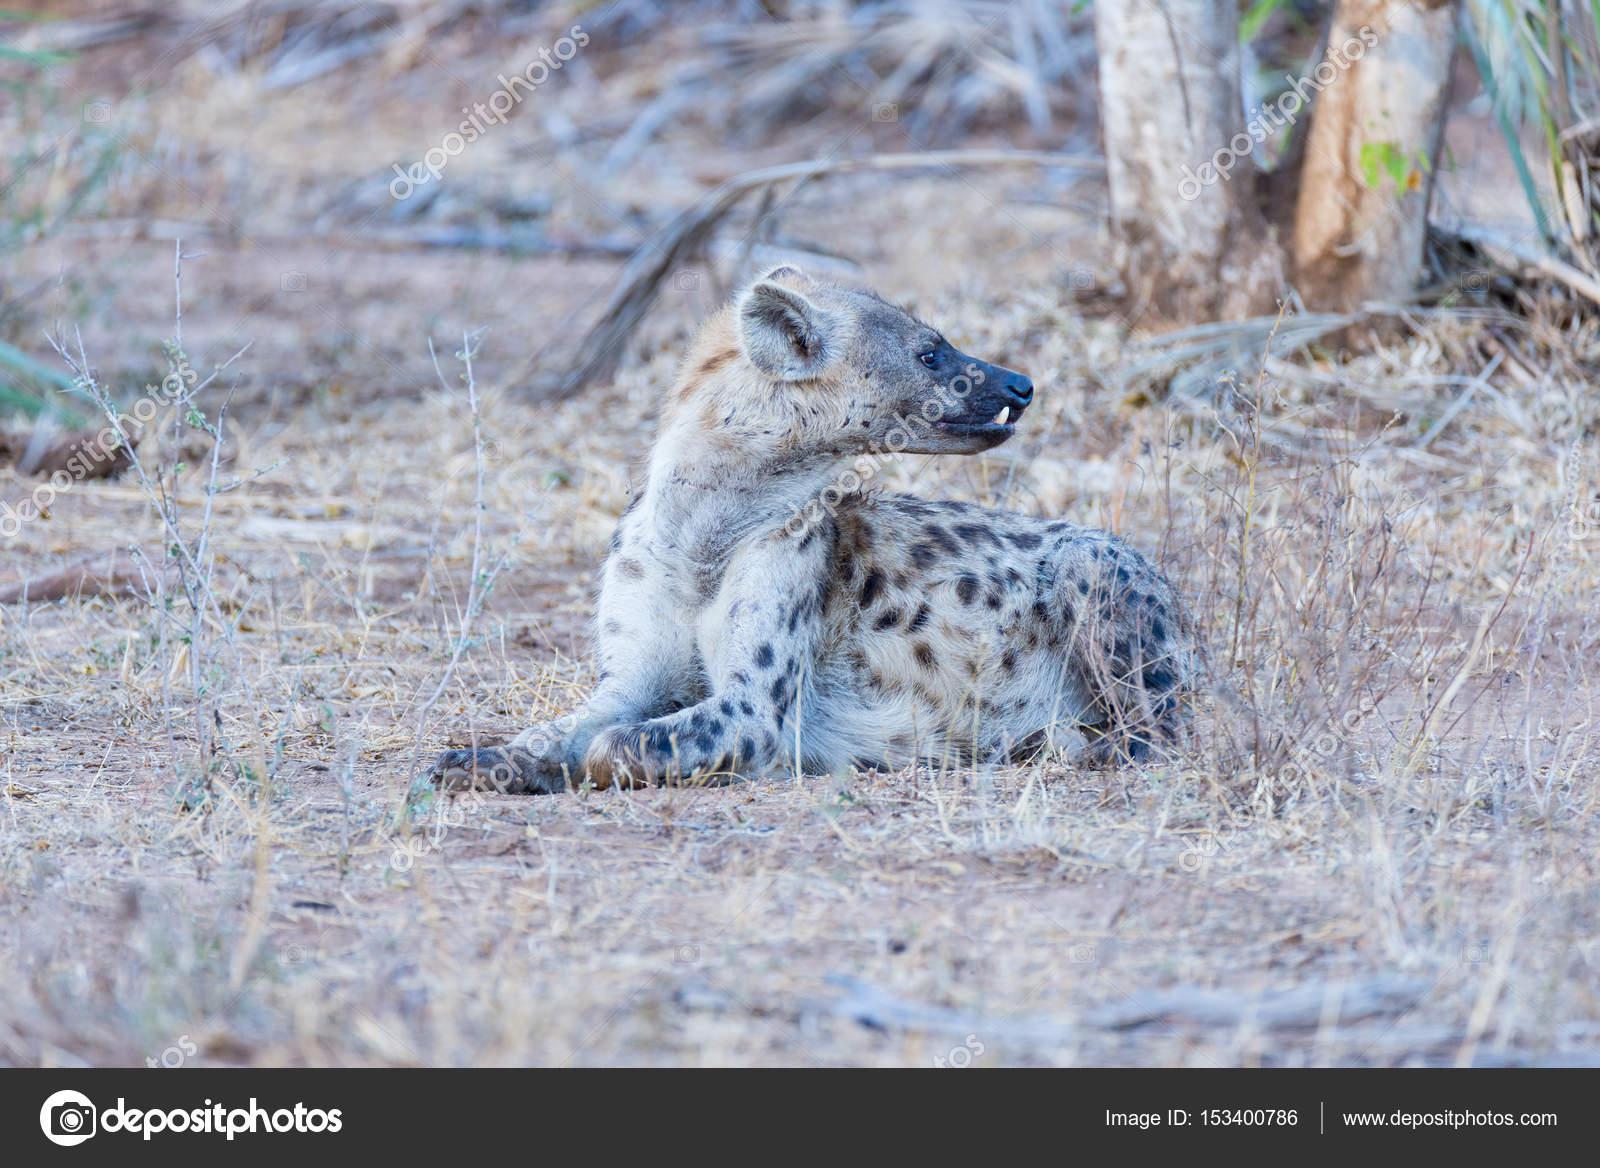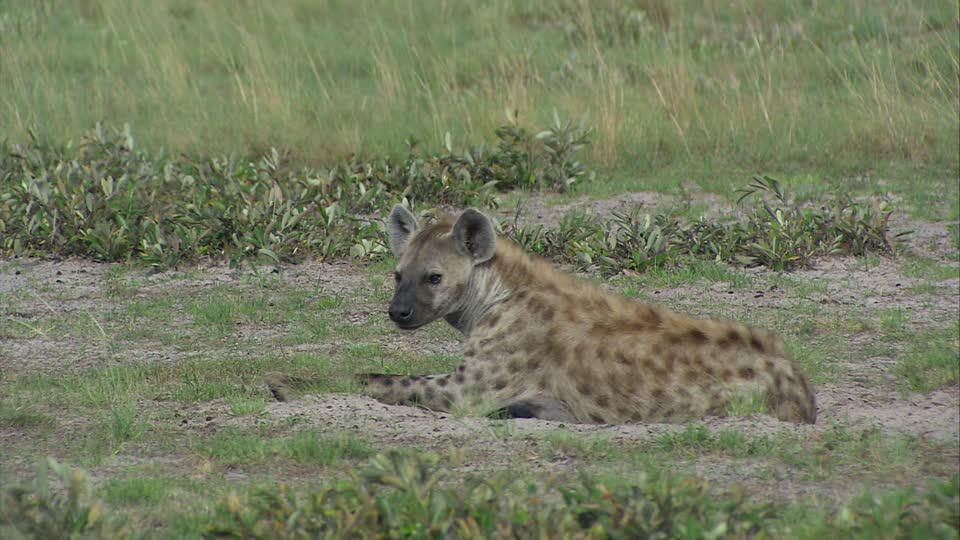The first image is the image on the left, the second image is the image on the right. Assess this claim about the two images: "Each image features one hyena with distinctive spotted fur, and the hyena on the left has its head turned around, while the hyena on the right reclines with its front paws extended.". Correct or not? Answer yes or no. Yes. The first image is the image on the left, the second image is the image on the right. Assess this claim about the two images: "There is a single adult hyena in each image, but they are looking in opposite directions.". Correct or not? Answer yes or no. Yes. 